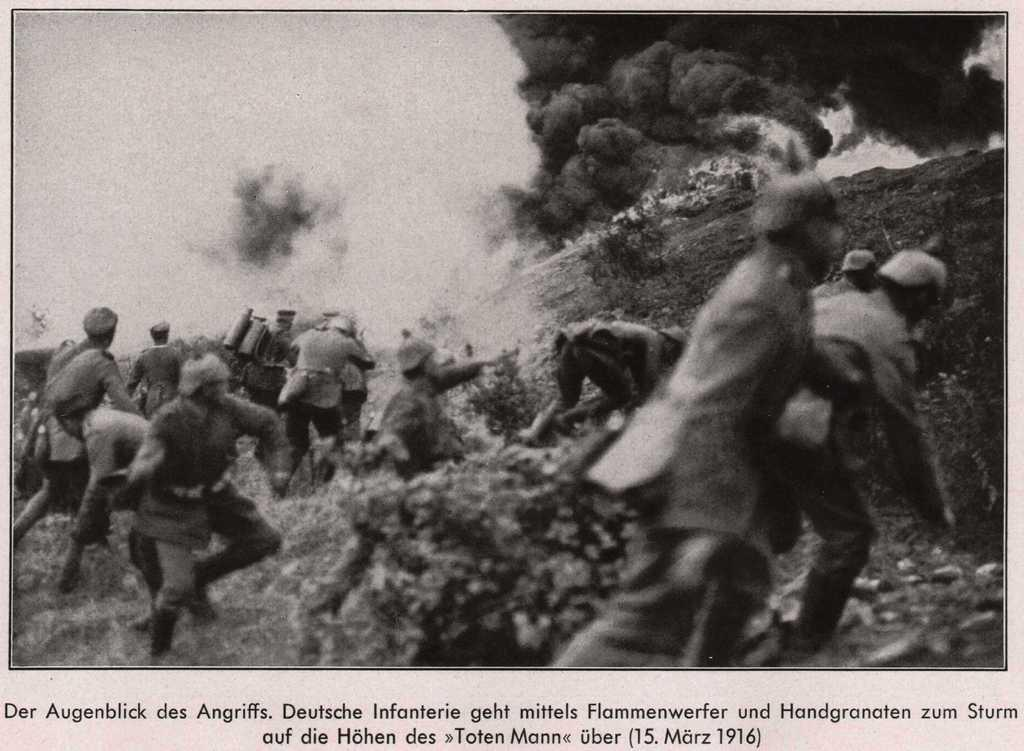What is happening on the ground in the image? There are people on the ground in the image. What else can be seen in the image besides the people? There is smoke visible in the image, and there are other objects present as well. Is there any text written on the image? Yes, there is text written on the image. What is the color scheme of the image? The image is black and white in color. What type of pancake is being served in the image? There is no pancake present in the image. What degree of difficulty is the task being performed in the image? The image does not depict a task or a level of difficulty, so this question cannot be answered. 